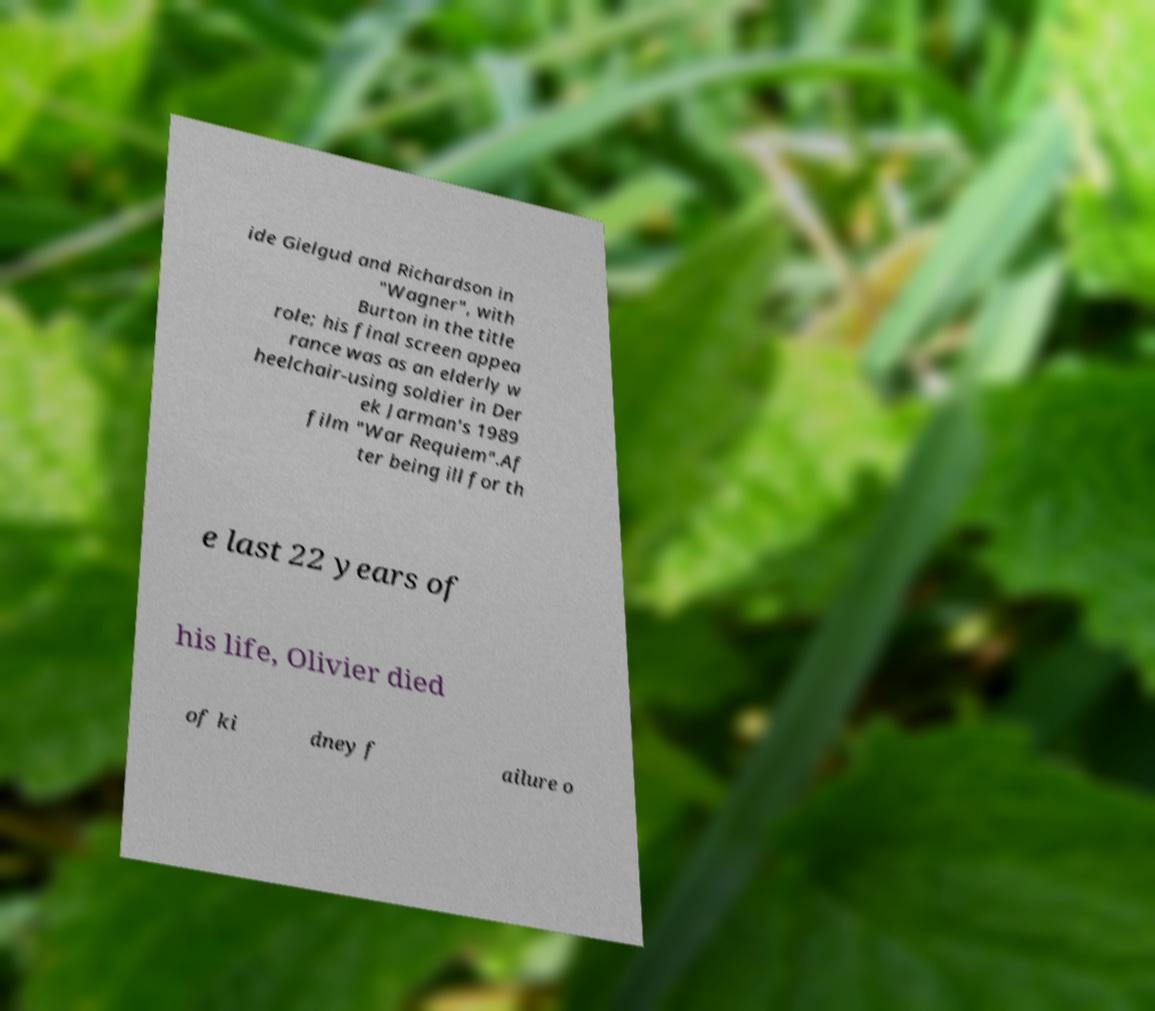Please identify and transcribe the text found in this image. ide Gielgud and Richardson in "Wagner", with Burton in the title role; his final screen appea rance was as an elderly w heelchair-using soldier in Der ek Jarman's 1989 film "War Requiem".Af ter being ill for th e last 22 years of his life, Olivier died of ki dney f ailure o 